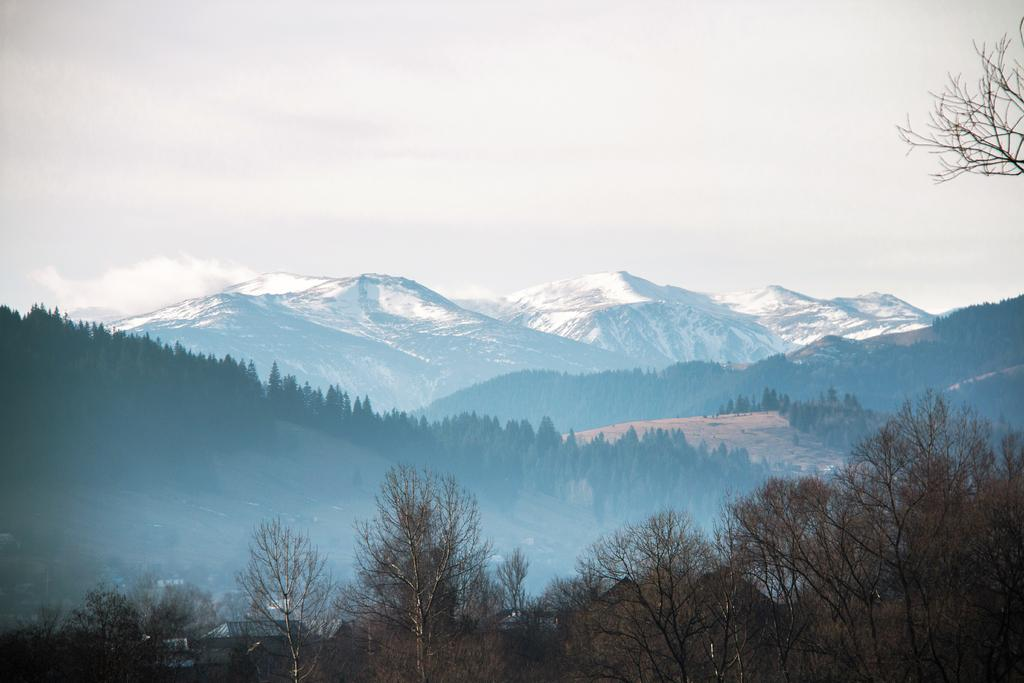What type of vegetation is at the front of the image? There are trees at the front of the image. What type of natural formation can be seen in the background of the image? There are mountains in the background of the image. What is visible in the sky in the background of the image? The sky is visible in the background of the image. Is there a berry that is being attacked by a rainstorm in the image? There is no berry or rainstorm present in the image. 